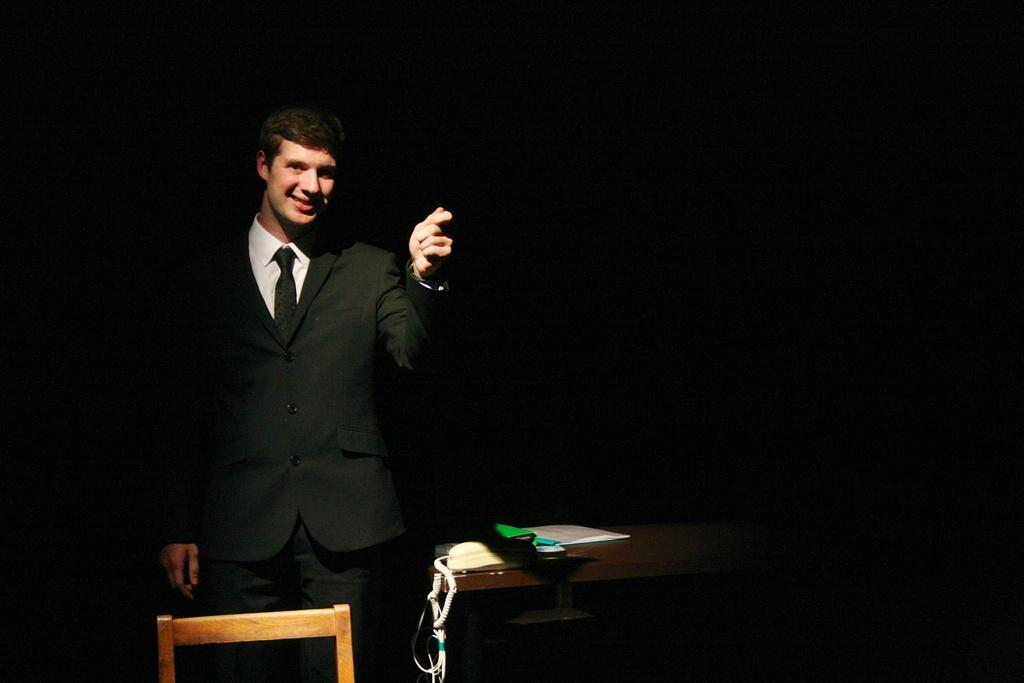What is the main subject of the image? The main subject of the image is a man. What is the man wearing in the image? The man is wearing a blazer and a tie in the image. What is the man's facial expression in the image? The man is smiling in the image. What is the man's posture in the image? The man is standing in the image. What object can be seen near the man in the image? There is a telephone in the image. What objects can be seen on a table in the image? There are books on a table in the image. What is the color of the background in the image? The background of the image is dark. How many passengers are visible in the image? There are no passengers visible in the image; it features a man standing near a telephone. What type of hole can be seen in the man's tie in the image? There is no hole in the man's tie in the image; it is a solid piece of fabric. 